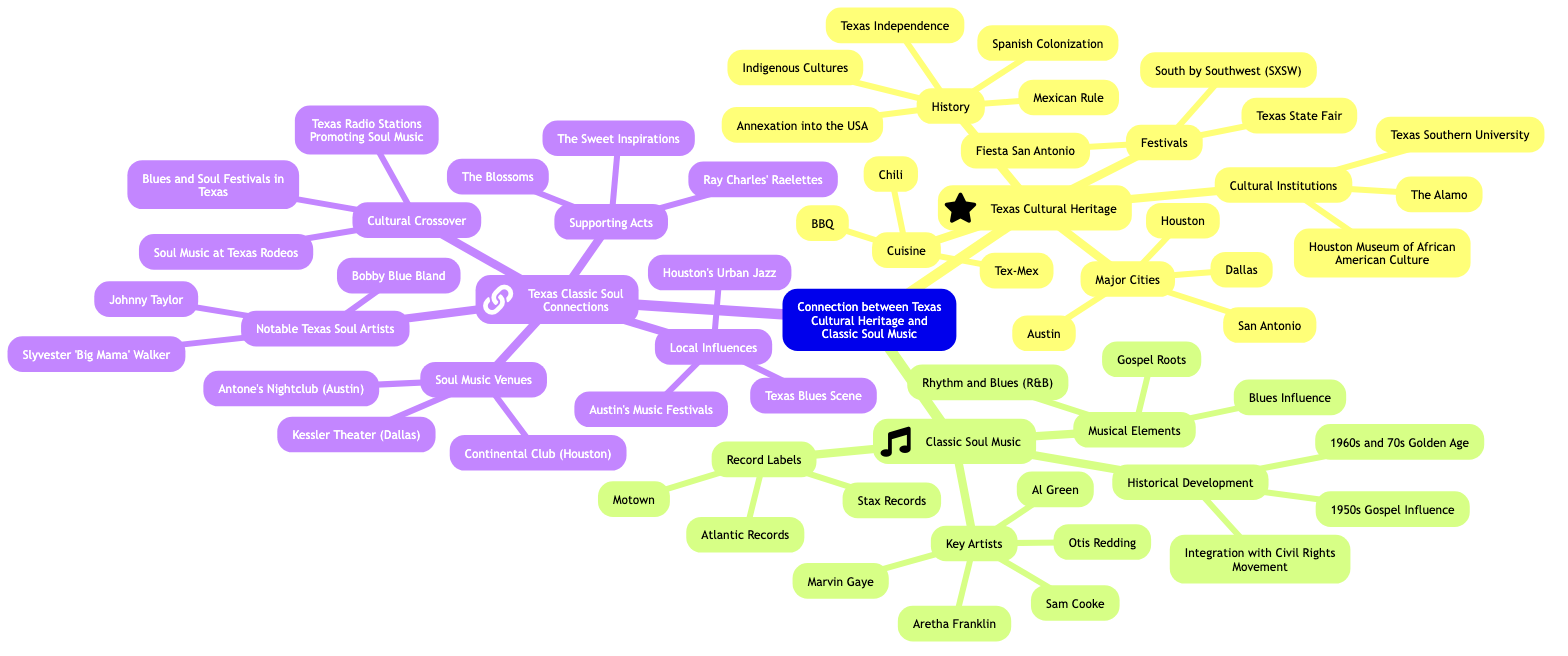What are the major cities listed under Texas Cultural Heritage? The diagram lists "Austin," "Houston," "Dallas," and "San Antonio" under the "Major Cities" node of Texas Cultural Heritage.
Answer: Austin, Houston, Dallas, San Antonio How many key artists are noted in Classic Soul Music? There are five key artists listed: Aretha Franklin, Sam Cooke, Otis Redding, Marvin Gaye, and Al Green. Counting these gives a total of five.
Answer: 5 What are some notable Texas soul artists mentioned? The listed notable Texas soul artists are "Bobby Blue Bland," "Johnny Taylor," and "Slyvester 'Big Mama' Walker."
Answer: Bobby Blue Bland, Johnny Taylor, Slyvester 'Big Mama' Walker Which music genres influence the Musical Elements of Classic Soul Music? The influences listed are "Gospel Roots," "Blues Influence," and "Rhythm and Blues (R&B)."
Answer: Gospel Roots, Blues Influence, Rhythm and Blues (R&B) What connection is highlighted between Texas and the Civil Rights Movement? The diagram points out the "Integration with Civil Rights Movement" under Historical Development in Classic Soul Music, indicating a direct link.
Answer: Integration with Civil Rights Movement How many cultural institutions are listed under Texas Cultural Heritage? The list includes "The Alamo," "Houston Museum of African American Culture," and "Texas Southern University," providing a total of three.
Answer: 3 What venues support soul music in Texas? The venues listed are "Antone's Nightclub (Austin)," "Continental Club (Houston)," and "Kessler Theater (Dallas)."
Answer: Antone's Nightclub, Continental Club, Kessler Theater What role do Texas radio stations play in soul music? The diagram mentions "Texas Radio Stations Promoting Soul Music," indicating their role in the promotion of the genre.
Answer: Texas Radio Stations Promoting Soul Music Which festival is noted for its location in Texas? "South by Southwest (SXSW)" is highlighted as a festival that takes place in Texas.
Answer: South by Southwest (SXSW) 